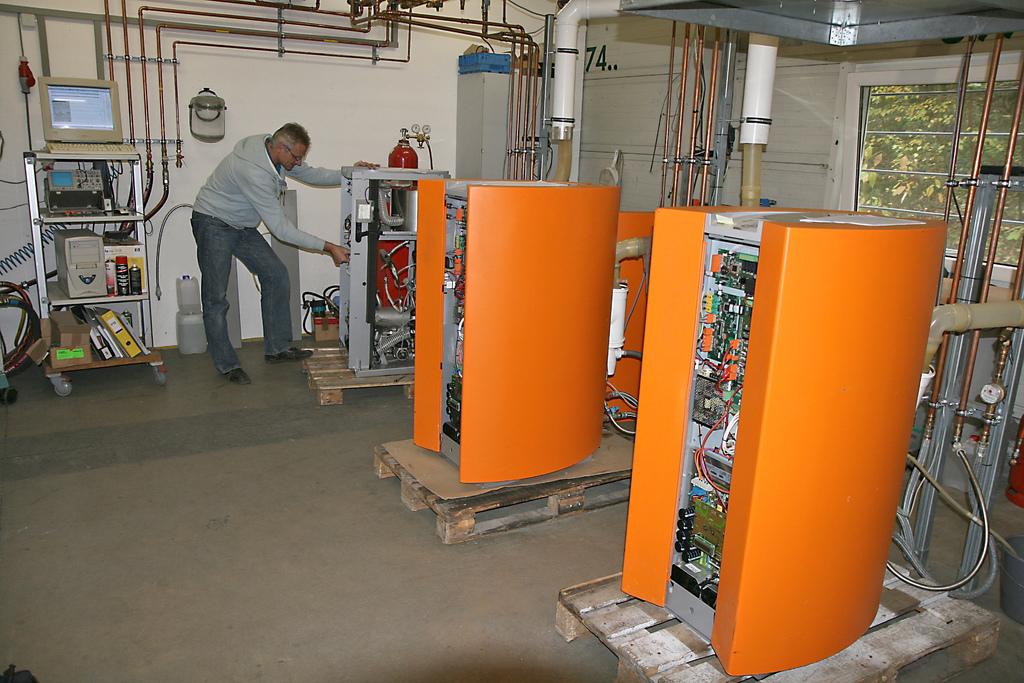What number is on the wall?
Offer a terse response. 74. 